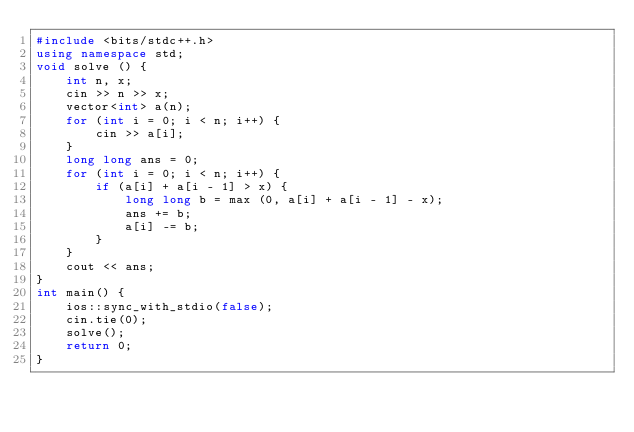Convert code to text. <code><loc_0><loc_0><loc_500><loc_500><_C++_>#include <bits/stdc++.h>
using namespace std;
void solve () {
    int n, x;
    cin >> n >> x;
    vector<int> a(n);
    for (int i = 0; i < n; i++) {
        cin >> a[i];
    }
    long long ans = 0;
    for (int i = 0; i < n; i++) {
        if (a[i] + a[i - 1] > x) {
            long long b = max (0, a[i] + a[i - 1] - x);
            ans += b;
            a[i] -= b;
        }
    }
    cout << ans;
}
int main() {
    ios::sync_with_stdio(false);
    cin.tie(0);
    solve();
    return 0;
}
</code> 